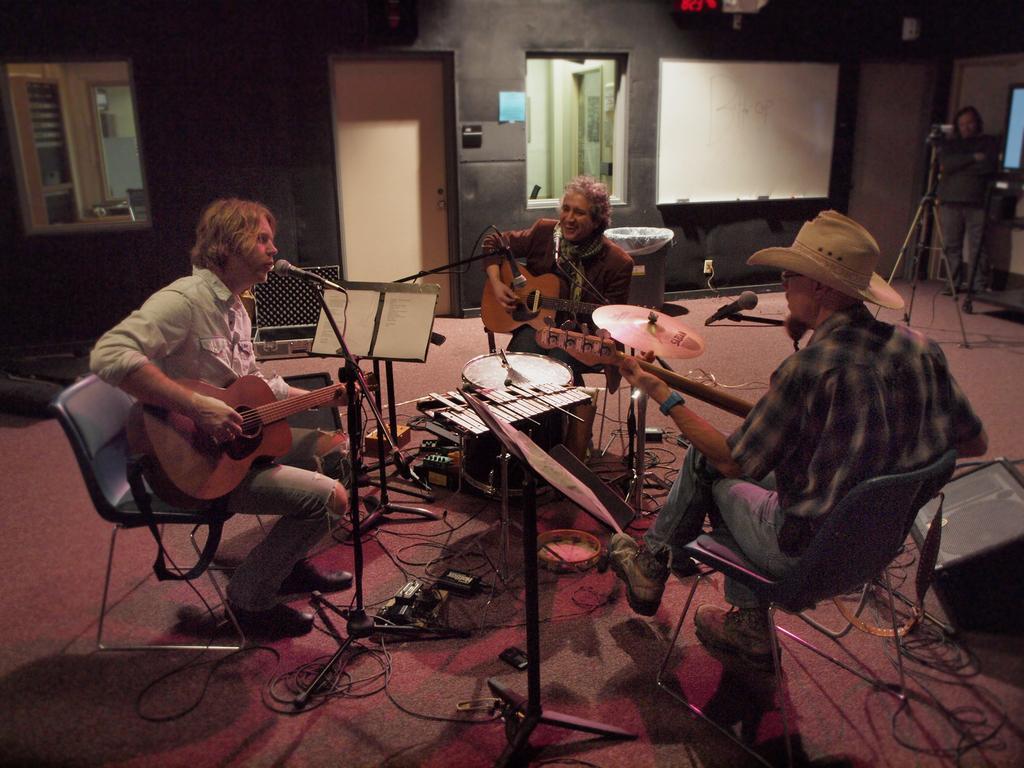Could you give a brief overview of what you see in this image? In this picture, we see three men are sitting on the chairs and they are playing guitars. In front of them, we see microphones. Two of them are singing the song on the microphone. In between them, we see drums and other musical instruments. Behind them, we see a grey color wall on which white board is placed. We even see the door and windows. On the right side, the man in black jacket is standing beside the camera stand. 